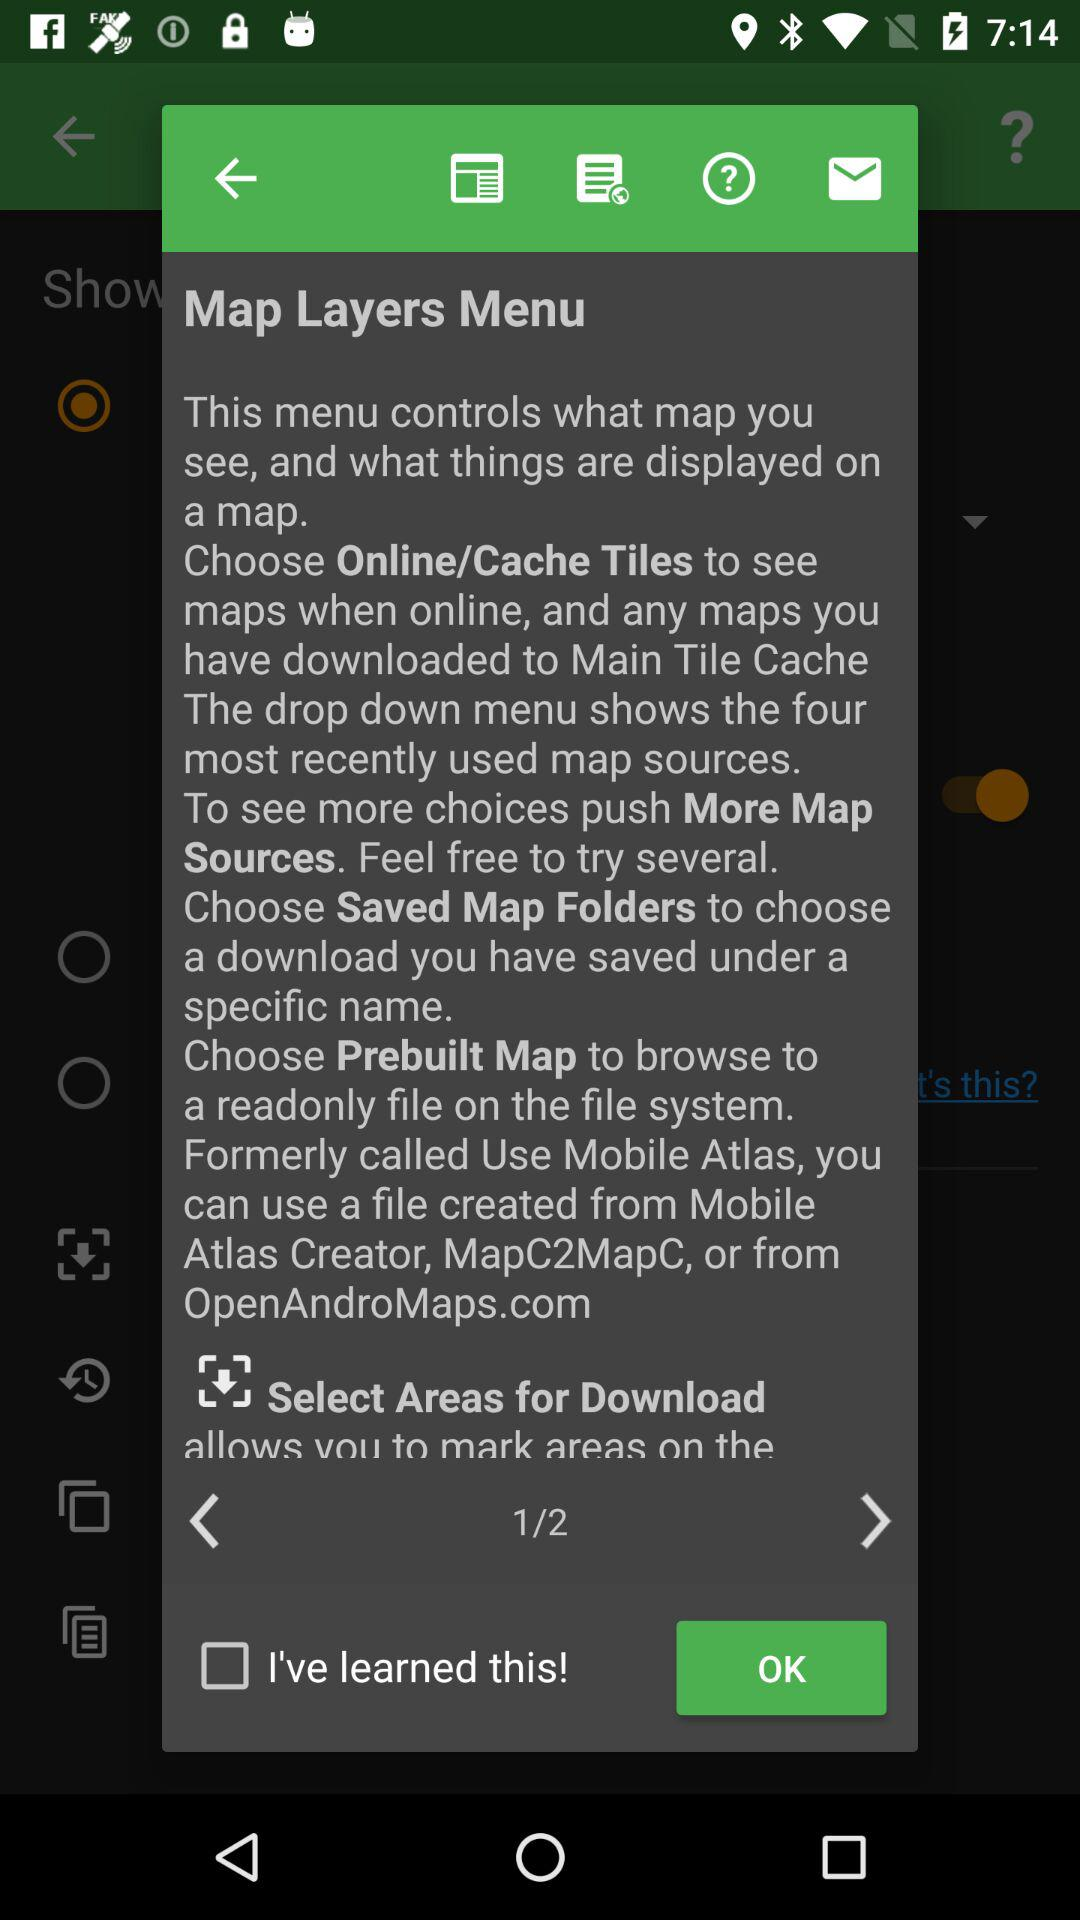Which page is the person on? The person is on page 1. 